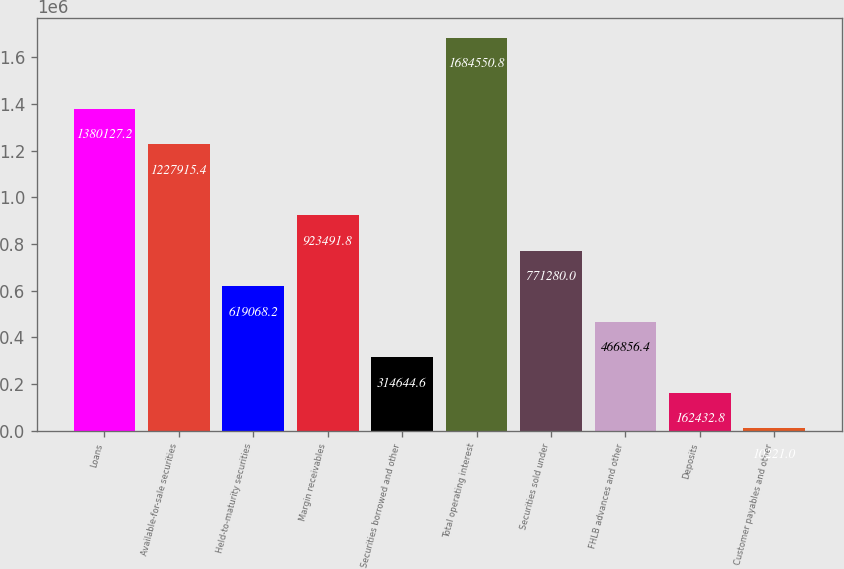Convert chart. <chart><loc_0><loc_0><loc_500><loc_500><bar_chart><fcel>Loans<fcel>Available-for-sale securities<fcel>Held-to-maturity securities<fcel>Margin receivables<fcel>Securities borrowed and other<fcel>Total operating interest<fcel>Securities sold under<fcel>FHLB advances and other<fcel>Deposits<fcel>Customer payables and other<nl><fcel>1.38013e+06<fcel>1.22792e+06<fcel>619068<fcel>923492<fcel>314645<fcel>1.68455e+06<fcel>771280<fcel>466856<fcel>162433<fcel>10221<nl></chart> 